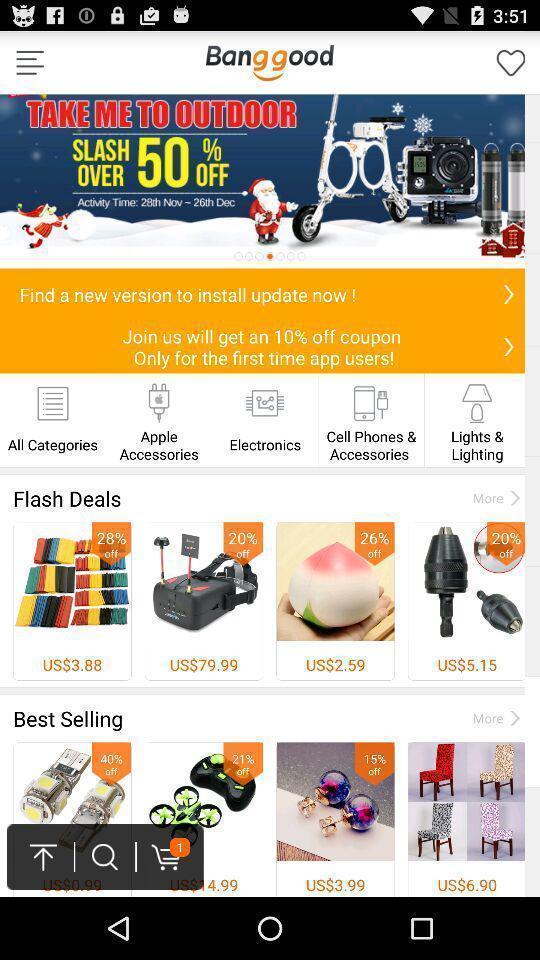What details can you identify in this image? Page showing offers and products from a shopping app. 